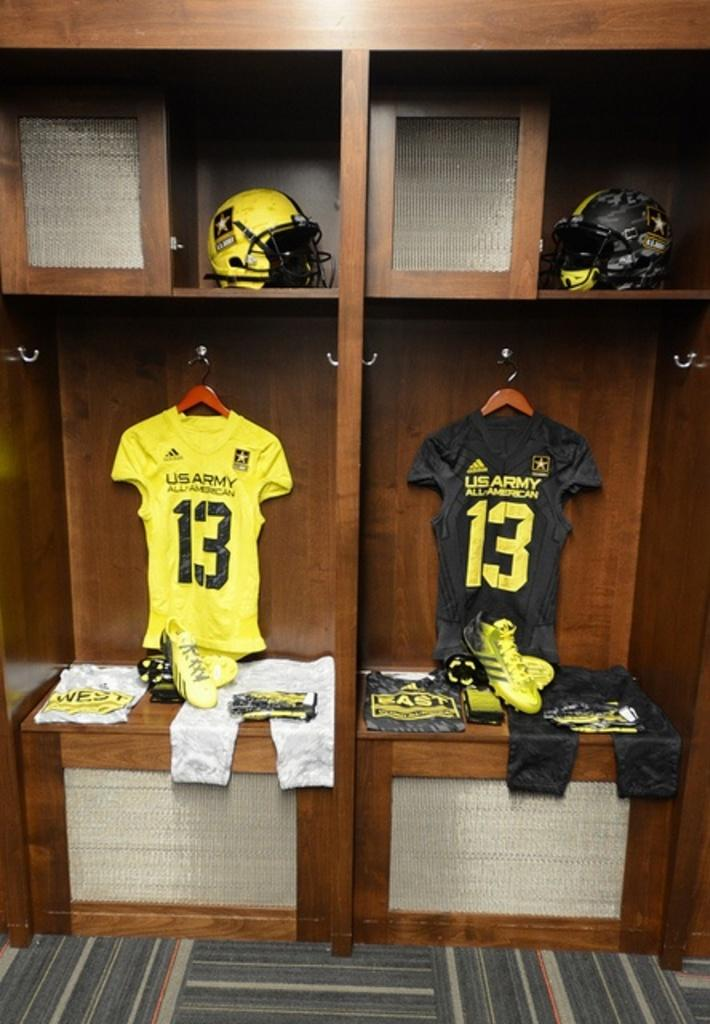<image>
Give a short and clear explanation of the subsequent image. Two Jerseys with the number 13 and US Army on the back sit in two lockers side by side. 